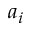Convert formula to latex. <formula><loc_0><loc_0><loc_500><loc_500>a _ { i }</formula> 